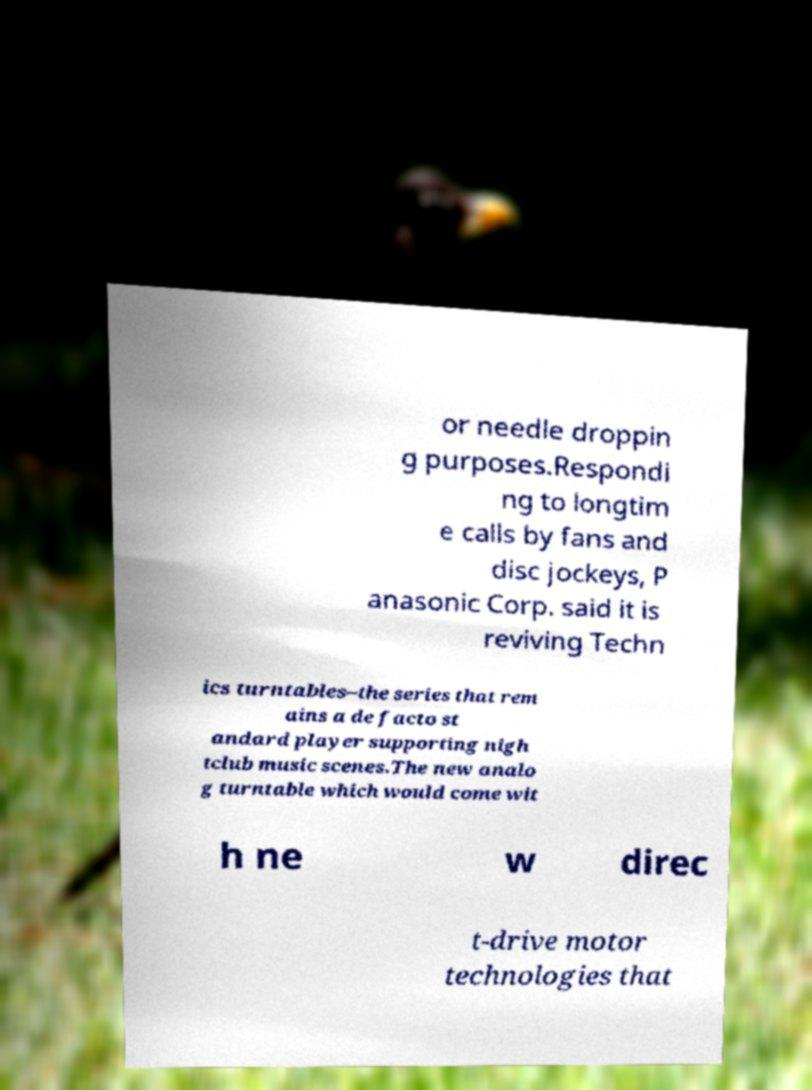Please read and relay the text visible in this image. What does it say? or needle droppin g purposes.Respondi ng to longtim e calls by fans and disc jockeys, P anasonic Corp. said it is reviving Techn ics turntables–the series that rem ains a de facto st andard player supporting nigh tclub music scenes.The new analo g turntable which would come wit h ne w direc t-drive motor technologies that 